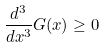Convert formula to latex. <formula><loc_0><loc_0><loc_500><loc_500>\frac { d ^ { 3 } } { d x ^ { 3 } } G ( x ) \geq 0</formula> 